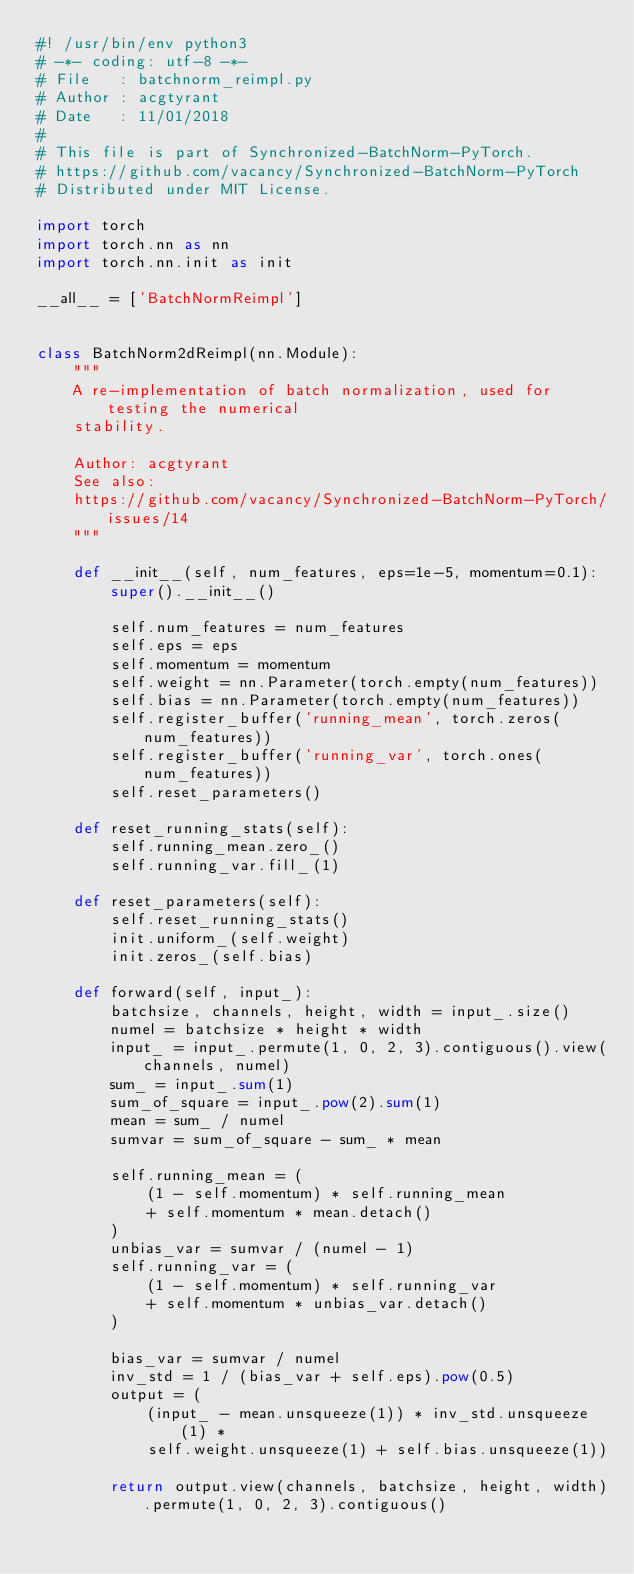Convert code to text. <code><loc_0><loc_0><loc_500><loc_500><_Python_>#! /usr/bin/env python3
# -*- coding: utf-8 -*-
# File   : batchnorm_reimpl.py
# Author : acgtyrant
# Date   : 11/01/2018
#
# This file is part of Synchronized-BatchNorm-PyTorch.
# https://github.com/vacancy/Synchronized-BatchNorm-PyTorch
# Distributed under MIT License.

import torch
import torch.nn as nn
import torch.nn.init as init

__all__ = ['BatchNormReimpl']


class BatchNorm2dReimpl(nn.Module):
    """
    A re-implementation of batch normalization, used for testing the numerical
    stability.

    Author: acgtyrant
    See also:
    https://github.com/vacancy/Synchronized-BatchNorm-PyTorch/issues/14
    """

    def __init__(self, num_features, eps=1e-5, momentum=0.1):
        super().__init__()

        self.num_features = num_features
        self.eps = eps
        self.momentum = momentum
        self.weight = nn.Parameter(torch.empty(num_features))
        self.bias = nn.Parameter(torch.empty(num_features))
        self.register_buffer('running_mean', torch.zeros(num_features))
        self.register_buffer('running_var', torch.ones(num_features))
        self.reset_parameters()

    def reset_running_stats(self):
        self.running_mean.zero_()
        self.running_var.fill_(1)

    def reset_parameters(self):
        self.reset_running_stats()
        init.uniform_(self.weight)
        init.zeros_(self.bias)

    def forward(self, input_):
        batchsize, channels, height, width = input_.size()
        numel = batchsize * height * width
        input_ = input_.permute(1, 0, 2, 3).contiguous().view(channels, numel)
        sum_ = input_.sum(1)
        sum_of_square = input_.pow(2).sum(1)
        mean = sum_ / numel
        sumvar = sum_of_square - sum_ * mean

        self.running_mean = (
            (1 - self.momentum) * self.running_mean
            + self.momentum * mean.detach()
        )
        unbias_var = sumvar / (numel - 1)
        self.running_var = (
            (1 - self.momentum) * self.running_var
            + self.momentum * unbias_var.detach()
        )

        bias_var = sumvar / numel
        inv_std = 1 / (bias_var + self.eps).pow(0.5)
        output = (
            (input_ - mean.unsqueeze(1)) * inv_std.unsqueeze(1) *
            self.weight.unsqueeze(1) + self.bias.unsqueeze(1))

        return output.view(channels, batchsize, height, width).permute(1, 0, 2, 3).contiguous()
</code> 